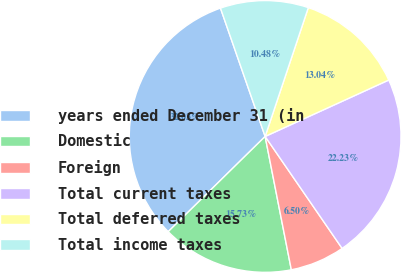Convert chart. <chart><loc_0><loc_0><loc_500><loc_500><pie_chart><fcel>years ended December 31 (in<fcel>Domestic<fcel>Foreign<fcel>Total current taxes<fcel>Total deferred taxes<fcel>Total income taxes<nl><fcel>32.03%<fcel>15.73%<fcel>6.5%<fcel>22.23%<fcel>13.04%<fcel>10.48%<nl></chart> 